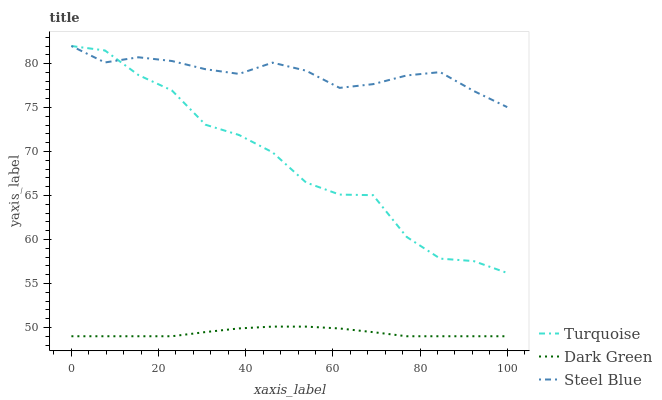Does Dark Green have the minimum area under the curve?
Answer yes or no. Yes. Does Steel Blue have the maximum area under the curve?
Answer yes or no. Yes. Does Steel Blue have the minimum area under the curve?
Answer yes or no. No. Does Dark Green have the maximum area under the curve?
Answer yes or no. No. Is Dark Green the smoothest?
Answer yes or no. Yes. Is Turquoise the roughest?
Answer yes or no. Yes. Is Steel Blue the smoothest?
Answer yes or no. No. Is Steel Blue the roughest?
Answer yes or no. No. Does Dark Green have the lowest value?
Answer yes or no. Yes. Does Steel Blue have the lowest value?
Answer yes or no. No. Does Steel Blue have the highest value?
Answer yes or no. Yes. Does Dark Green have the highest value?
Answer yes or no. No. Is Dark Green less than Steel Blue?
Answer yes or no. Yes. Is Turquoise greater than Dark Green?
Answer yes or no. Yes. Does Turquoise intersect Steel Blue?
Answer yes or no. Yes. Is Turquoise less than Steel Blue?
Answer yes or no. No. Is Turquoise greater than Steel Blue?
Answer yes or no. No. Does Dark Green intersect Steel Blue?
Answer yes or no. No. 